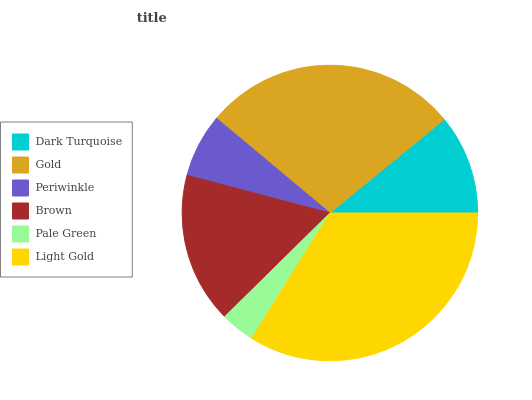Is Pale Green the minimum?
Answer yes or no. Yes. Is Light Gold the maximum?
Answer yes or no. Yes. Is Gold the minimum?
Answer yes or no. No. Is Gold the maximum?
Answer yes or no. No. Is Gold greater than Dark Turquoise?
Answer yes or no. Yes. Is Dark Turquoise less than Gold?
Answer yes or no. Yes. Is Dark Turquoise greater than Gold?
Answer yes or no. No. Is Gold less than Dark Turquoise?
Answer yes or no. No. Is Brown the high median?
Answer yes or no. Yes. Is Dark Turquoise the low median?
Answer yes or no. Yes. Is Pale Green the high median?
Answer yes or no. No. Is Periwinkle the low median?
Answer yes or no. No. 